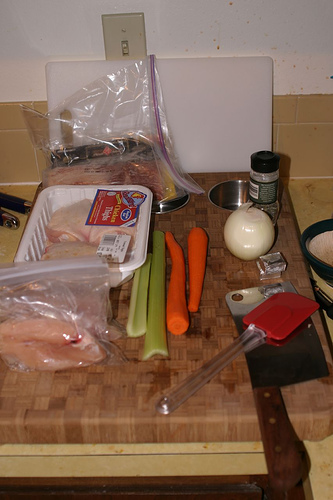<image>What produce is in the bag? I am unsure what produce is in the bag. It can be carrots, celery or meat. What produce is in the bag? It is unclear what produce is in the bag. It can be seen celery, carrots, chicken or a mix of vegetables and meat. 